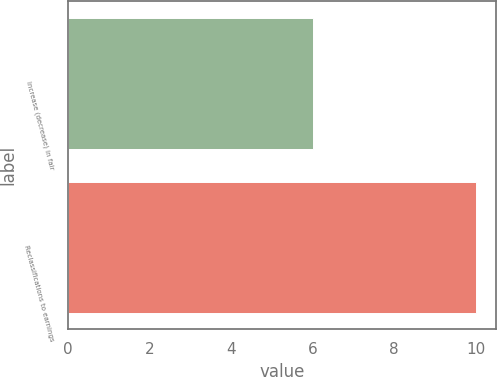Convert chart. <chart><loc_0><loc_0><loc_500><loc_500><bar_chart><fcel>Increase (decrease) in fair<fcel>Reclassifications to earnings<nl><fcel>6<fcel>10<nl></chart> 